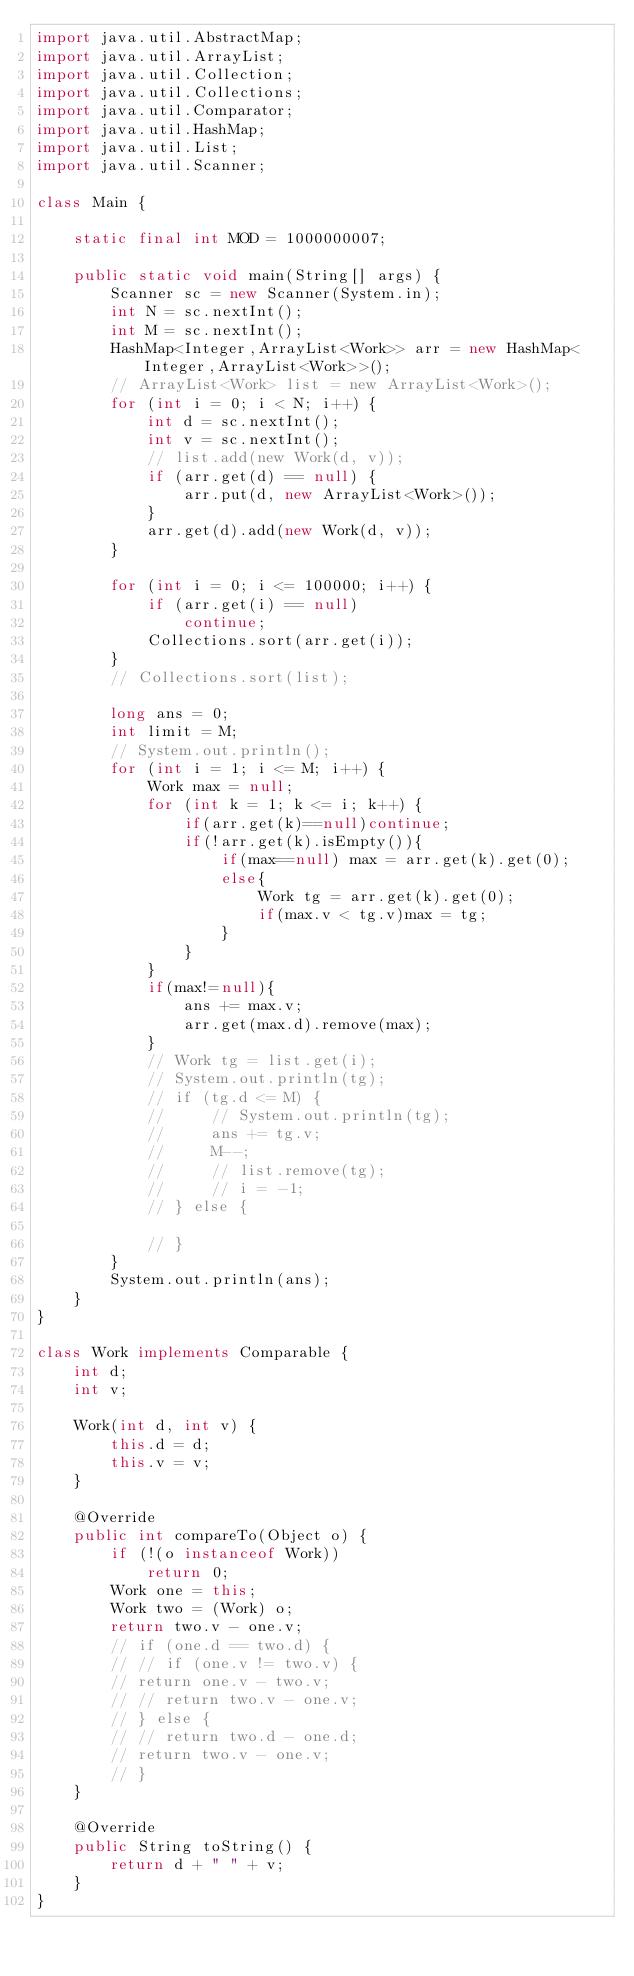<code> <loc_0><loc_0><loc_500><loc_500><_Java_>import java.util.AbstractMap;
import java.util.ArrayList;
import java.util.Collection;
import java.util.Collections;
import java.util.Comparator;
import java.util.HashMap;
import java.util.List;
import java.util.Scanner;

class Main {

    static final int MOD = 1000000007;

    public static void main(String[] args) {
        Scanner sc = new Scanner(System.in);
        int N = sc.nextInt();
        int M = sc.nextInt();
        HashMap<Integer,ArrayList<Work>> arr = new HashMap<Integer,ArrayList<Work>>();
        // ArrayList<Work> list = new ArrayList<Work>();
        for (int i = 0; i < N; i++) {
            int d = sc.nextInt();
            int v = sc.nextInt();
            // list.add(new Work(d, v));
            if (arr.get(d) == null) {
                arr.put(d, new ArrayList<Work>());
            }
            arr.get(d).add(new Work(d, v));
        }

        for (int i = 0; i <= 100000; i++) {
            if (arr.get(i) == null)
                continue;
            Collections.sort(arr.get(i));
        }
        // Collections.sort(list);

        long ans = 0;
        int limit = M;
        // System.out.println();
        for (int i = 1; i <= M; i++) {
            Work max = null;
            for (int k = 1; k <= i; k++) {
                if(arr.get(k)==null)continue;
                if(!arr.get(k).isEmpty()){
                    if(max==null) max = arr.get(k).get(0);
                    else{
                        Work tg = arr.get(k).get(0);
                        if(max.v < tg.v)max = tg;
                    }
                }
            }
            if(max!=null){
                ans += max.v;
                arr.get(max.d).remove(max);
            }
            // Work tg = list.get(i);
            // System.out.println(tg);
            // if (tg.d <= M) {
            //     // System.out.println(tg);
            //     ans += tg.v;
            //     M--;
            //     // list.remove(tg);
            //     // i = -1;
            // } else {

            // }
        }
        System.out.println(ans);
    }
}

class Work implements Comparable {
    int d;
    int v;

    Work(int d, int v) {
        this.d = d;
        this.v = v;
    }

    @Override
    public int compareTo(Object o) {
        if (!(o instanceof Work))
            return 0;
        Work one = this;
        Work two = (Work) o;
        return two.v - one.v;
        // if (one.d == two.d) {
        // // if (one.v != two.v) {
        // return one.v - two.v;
        // // return two.v - one.v;
        // } else {
        // // return two.d - one.d;
        // return two.v - one.v;
        // }
    }

    @Override
    public String toString() {
        return d + " " + v;
    }
}</code> 